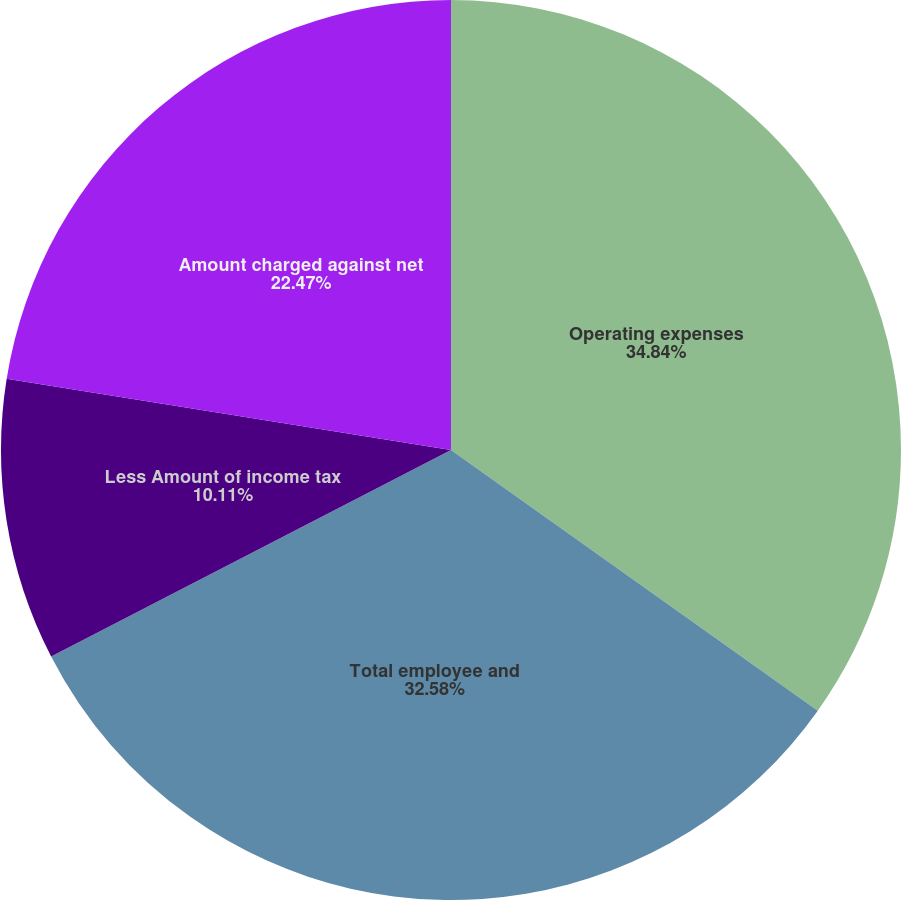<chart> <loc_0><loc_0><loc_500><loc_500><pie_chart><fcel>Operating expenses<fcel>Total employee and<fcel>Less Amount of income tax<fcel>Amount charged against net<nl><fcel>34.83%<fcel>32.58%<fcel>10.11%<fcel>22.47%<nl></chart> 